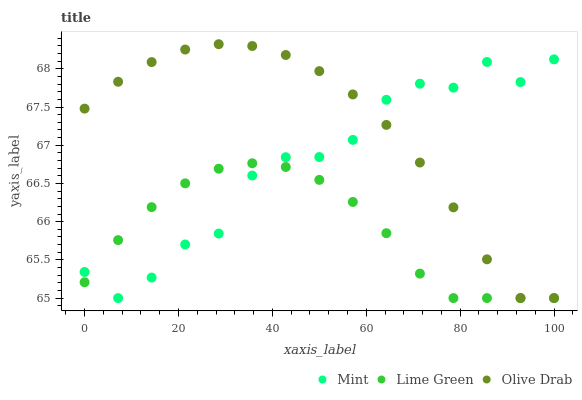Does Lime Green have the minimum area under the curve?
Answer yes or no. Yes. Does Olive Drab have the maximum area under the curve?
Answer yes or no. Yes. Does Mint have the minimum area under the curve?
Answer yes or no. No. Does Mint have the maximum area under the curve?
Answer yes or no. No. Is Lime Green the smoothest?
Answer yes or no. Yes. Is Mint the roughest?
Answer yes or no. Yes. Is Olive Drab the smoothest?
Answer yes or no. No. Is Olive Drab the roughest?
Answer yes or no. No. Does Lime Green have the lowest value?
Answer yes or no. Yes. Does Olive Drab have the highest value?
Answer yes or no. Yes. Does Mint have the highest value?
Answer yes or no. No. Does Mint intersect Olive Drab?
Answer yes or no. Yes. Is Mint less than Olive Drab?
Answer yes or no. No. Is Mint greater than Olive Drab?
Answer yes or no. No. 